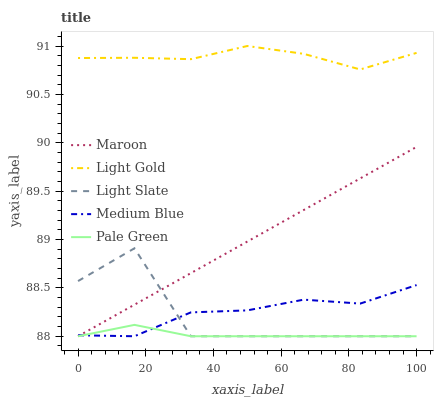Does Medium Blue have the minimum area under the curve?
Answer yes or no. No. Does Medium Blue have the maximum area under the curve?
Answer yes or no. No. Is Medium Blue the smoothest?
Answer yes or no. No. Is Medium Blue the roughest?
Answer yes or no. No. Does Light Gold have the lowest value?
Answer yes or no. No. Does Medium Blue have the highest value?
Answer yes or no. No. Is Light Slate less than Light Gold?
Answer yes or no. Yes. Is Light Gold greater than Light Slate?
Answer yes or no. Yes. Does Light Slate intersect Light Gold?
Answer yes or no. No. 